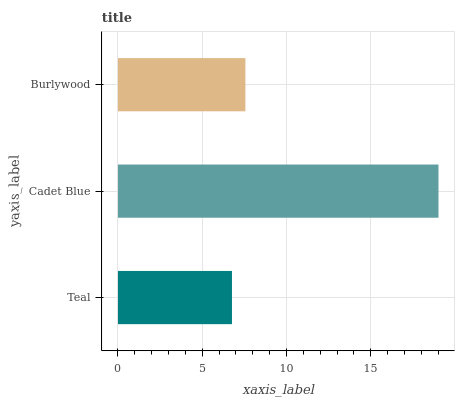Is Teal the minimum?
Answer yes or no. Yes. Is Cadet Blue the maximum?
Answer yes or no. Yes. Is Burlywood the minimum?
Answer yes or no. No. Is Burlywood the maximum?
Answer yes or no. No. Is Cadet Blue greater than Burlywood?
Answer yes or no. Yes. Is Burlywood less than Cadet Blue?
Answer yes or no. Yes. Is Burlywood greater than Cadet Blue?
Answer yes or no. No. Is Cadet Blue less than Burlywood?
Answer yes or no. No. Is Burlywood the high median?
Answer yes or no. Yes. Is Burlywood the low median?
Answer yes or no. Yes. Is Teal the high median?
Answer yes or no. No. Is Cadet Blue the low median?
Answer yes or no. No. 